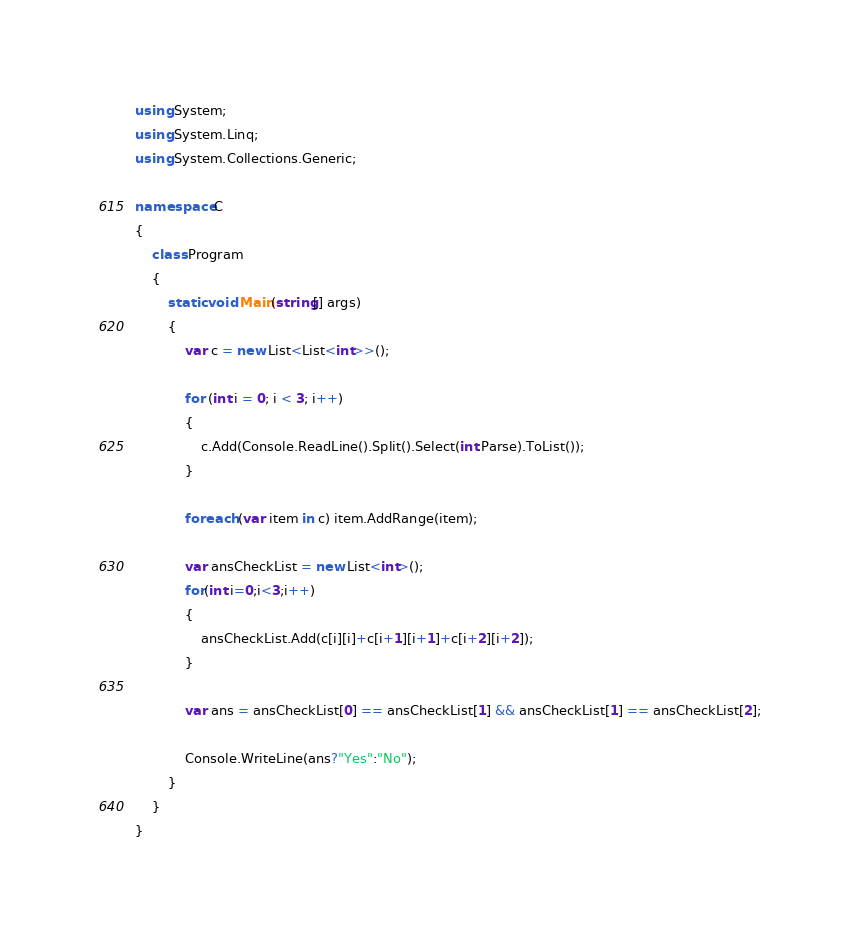Convert code to text. <code><loc_0><loc_0><loc_500><loc_500><_C#_>using System;
using System.Linq;
using System.Collections.Generic;

namespace C
{
    class Program
    {
        static void Main(string[] args)
        {
            var c = new List<List<int>>();

            for (int i = 0; i < 3; i++)
            {
                c.Add(Console.ReadLine().Split().Select(int.Parse).ToList());
            }

            foreach (var item in c) item.AddRange(item);

            var ansCheckList = new List<int>();
            for(int i=0;i<3;i++)
            {
                ansCheckList.Add(c[i][i]+c[i+1][i+1]+c[i+2][i+2]);
            }

            var ans = ansCheckList[0] == ansCheckList[1] && ansCheckList[1] == ansCheckList[2];
            
            Console.WriteLine(ans?"Yes":"No");
        }
    }
}
</code> 